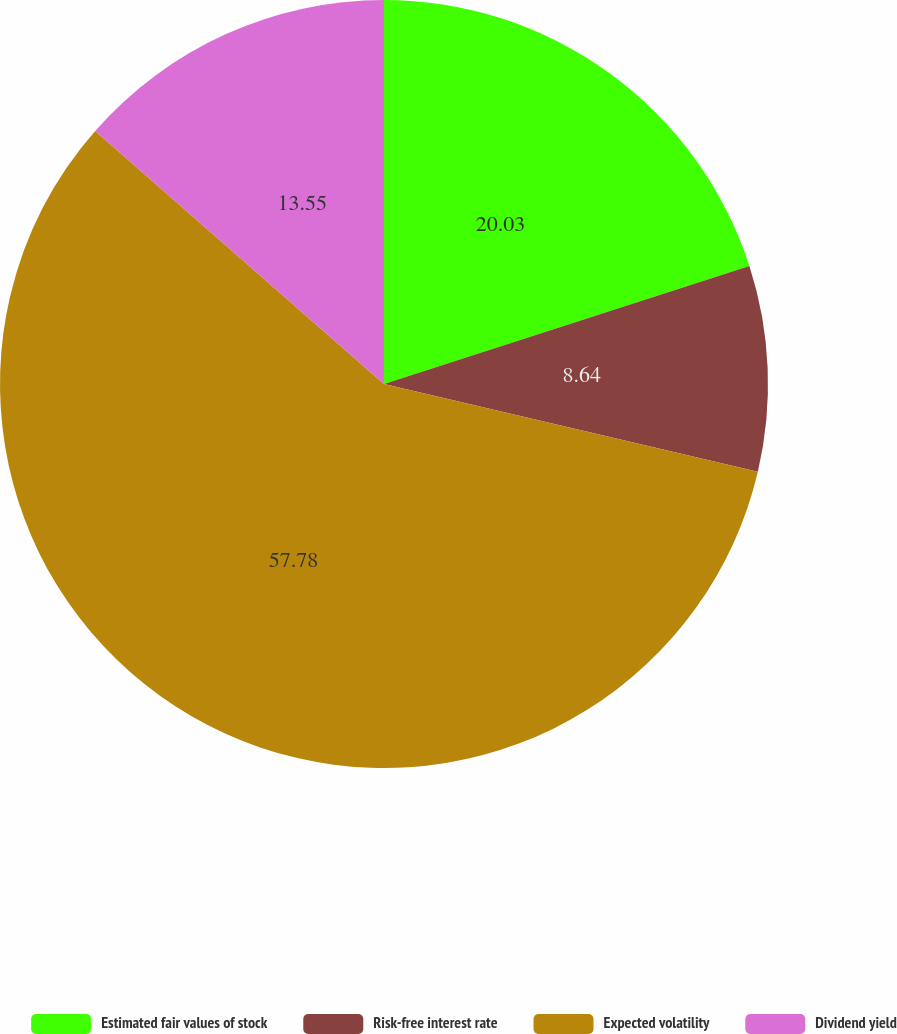Convert chart to OTSL. <chart><loc_0><loc_0><loc_500><loc_500><pie_chart><fcel>Estimated fair values of stock<fcel>Risk-free interest rate<fcel>Expected volatility<fcel>Dividend yield<nl><fcel>20.03%<fcel>8.64%<fcel>57.79%<fcel>13.55%<nl></chart> 